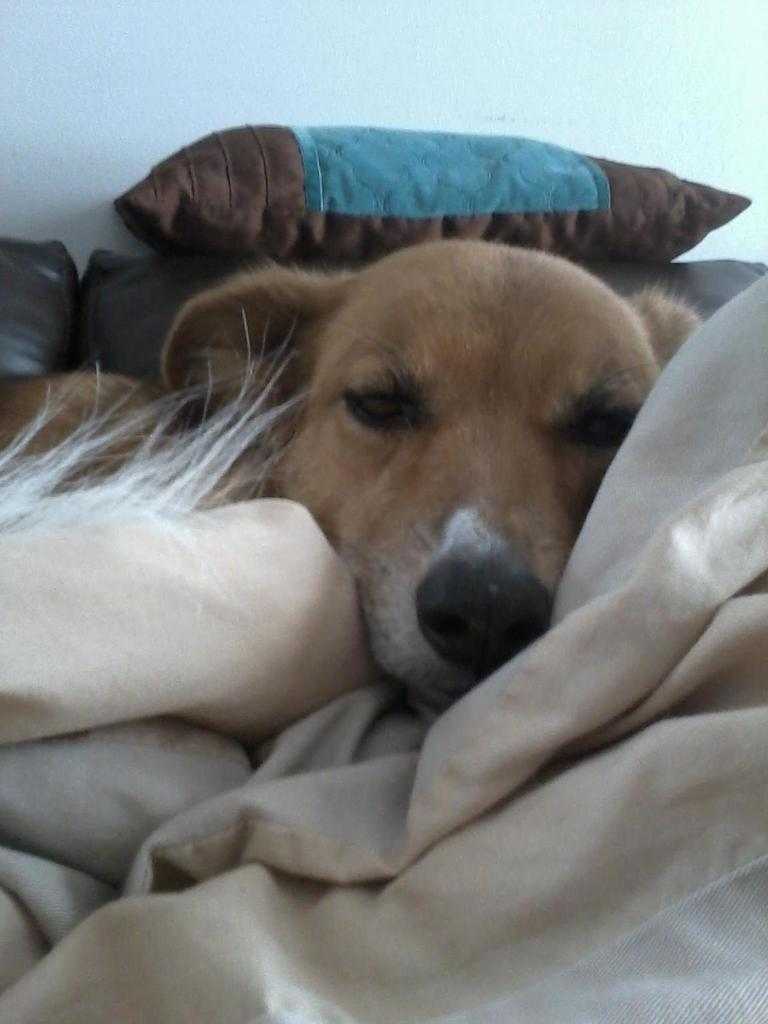What is the main subject in the center of the image? There is a dog in the center of the image. Where is the dog located? The dog is on a bed sheet. What can be seen in the background of the image? There is a pillow, a sofa, and a wall in the background of the image. Where is the nest located in the image? There is no nest present in the image. Can you see any ghosts in the image? There are no ghosts present in the image. 